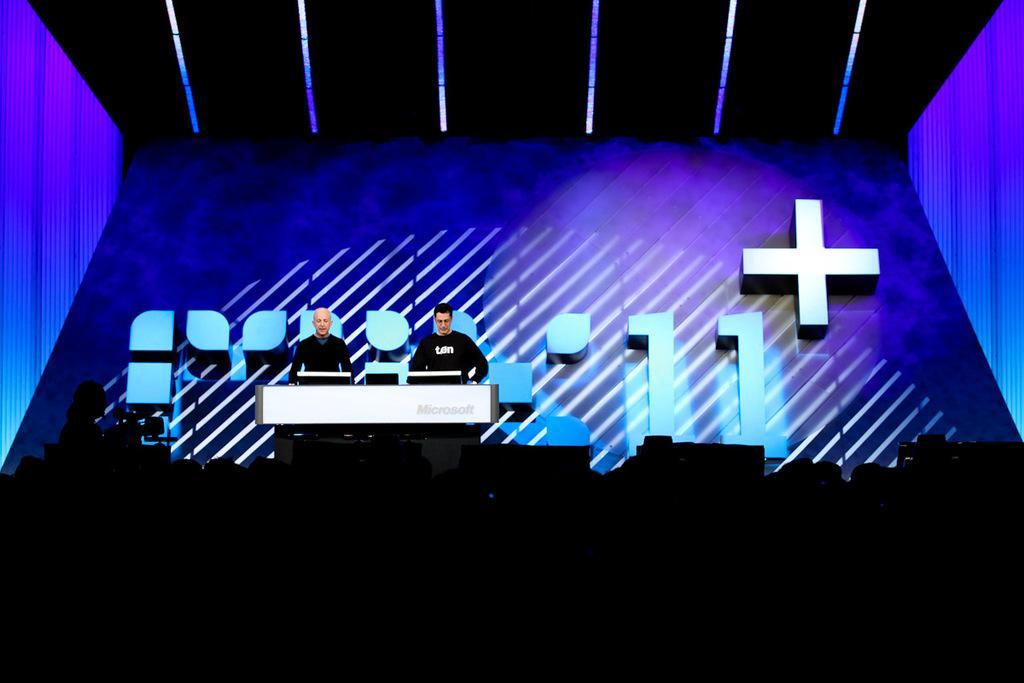Describe this image in one or two sentences. In this image we can see two persons wearing black color T-shirt standing on the stage behind something and in the background of the image there is blue color sheet and in the foreground of the image there are some persons sitting on chairs. 